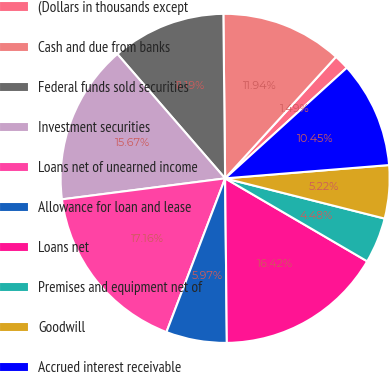<chart> <loc_0><loc_0><loc_500><loc_500><pie_chart><fcel>(Dollars in thousands except<fcel>Cash and due from banks<fcel>Federal funds sold securities<fcel>Investment securities<fcel>Loans net of unearned income<fcel>Allowance for loan and lease<fcel>Loans net<fcel>Premises and equipment net of<fcel>Goodwill<fcel>Accrued interest receivable<nl><fcel>1.49%<fcel>11.94%<fcel>11.19%<fcel>15.67%<fcel>17.16%<fcel>5.97%<fcel>16.42%<fcel>4.48%<fcel>5.22%<fcel>10.45%<nl></chart> 